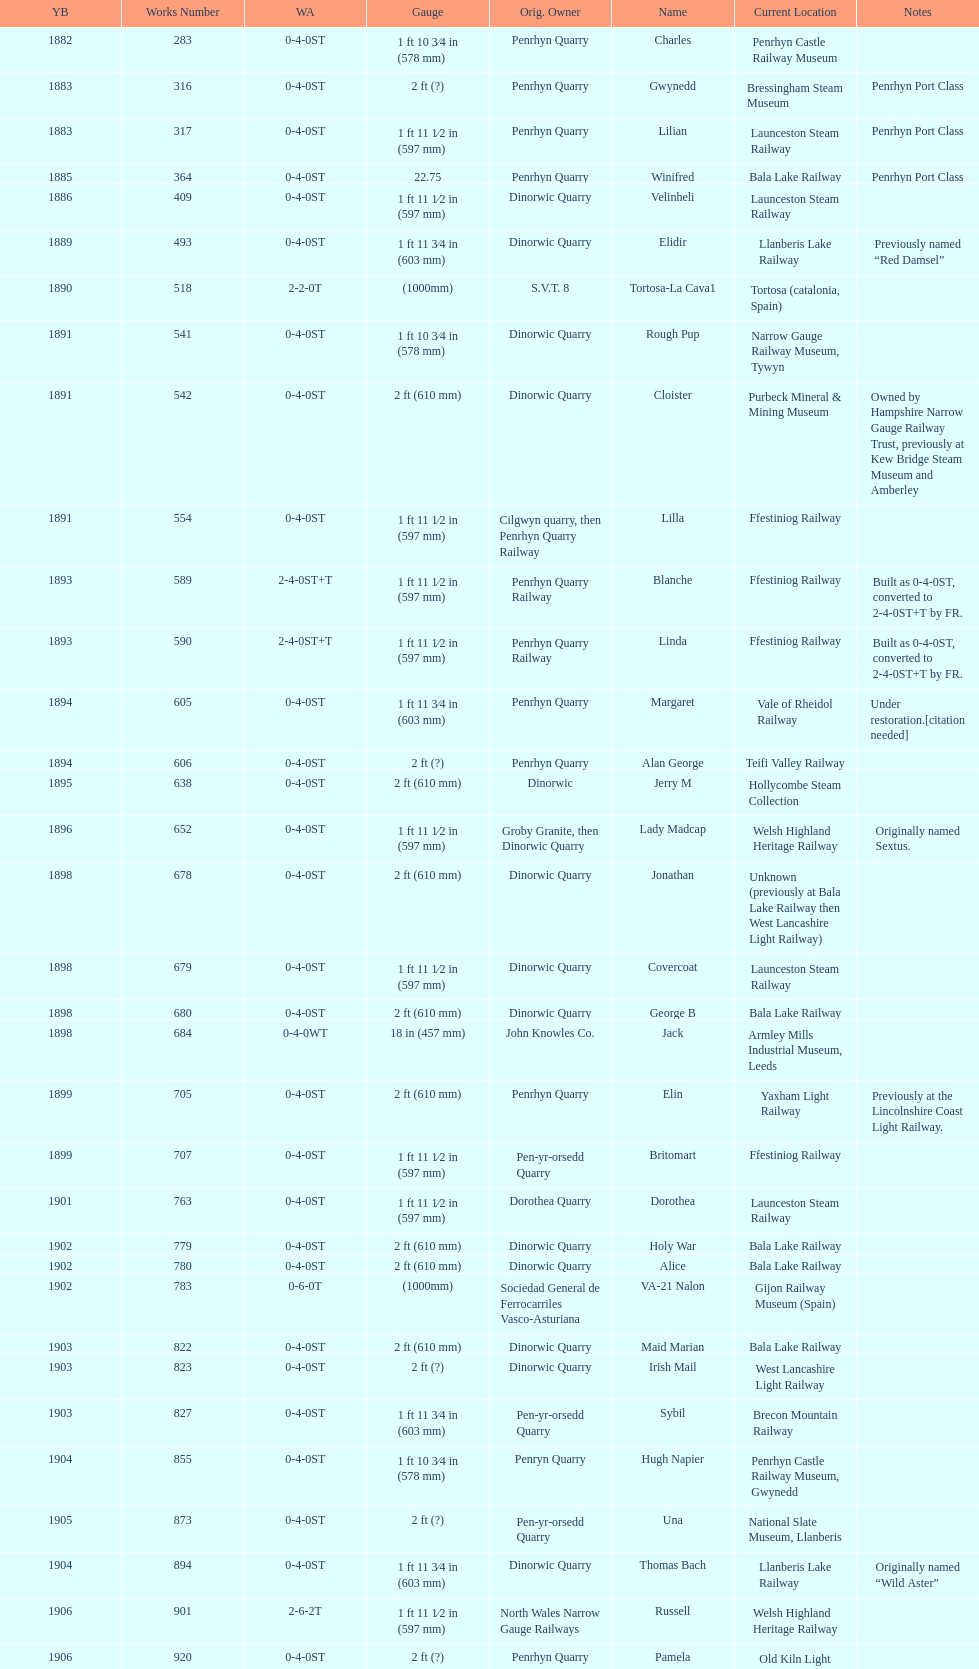What is the total number of preserved hunslet narrow gauge locomotives currently located in ffestiniog railway 554. 